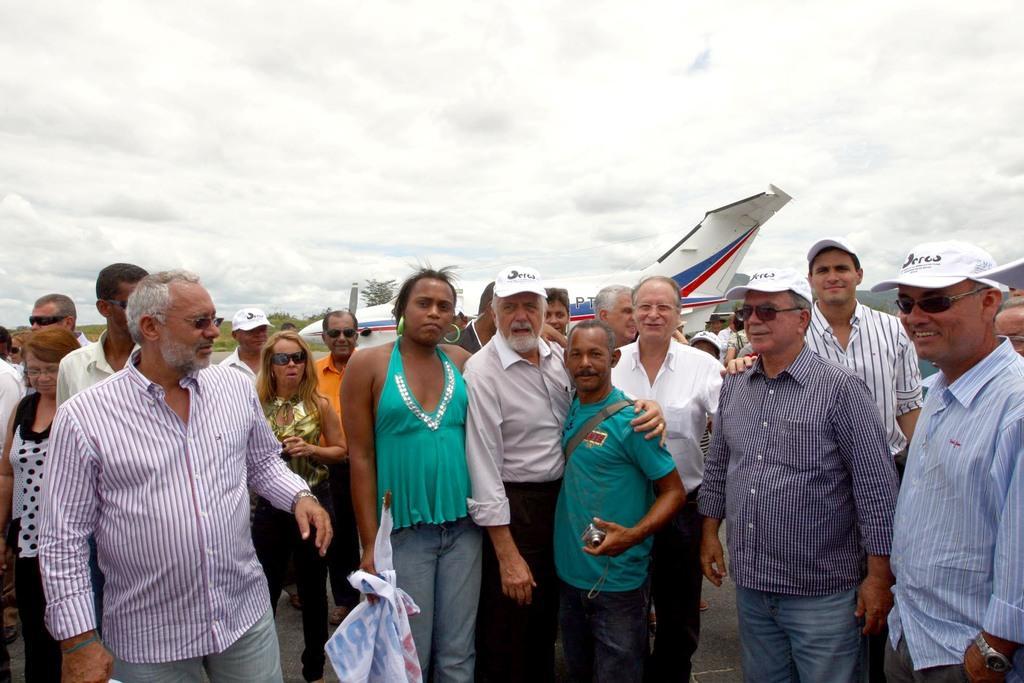Describe this image in one or two sentences. In the foreground of this image, there are persons standing. In the background, there is an airplane, sky and the cloud. 